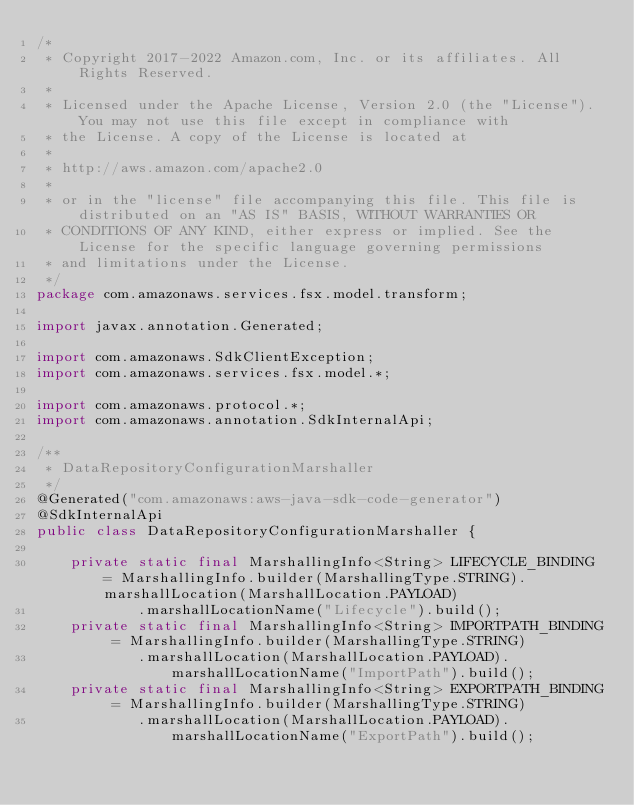Convert code to text. <code><loc_0><loc_0><loc_500><loc_500><_Java_>/*
 * Copyright 2017-2022 Amazon.com, Inc. or its affiliates. All Rights Reserved.
 * 
 * Licensed under the Apache License, Version 2.0 (the "License"). You may not use this file except in compliance with
 * the License. A copy of the License is located at
 * 
 * http://aws.amazon.com/apache2.0
 * 
 * or in the "license" file accompanying this file. This file is distributed on an "AS IS" BASIS, WITHOUT WARRANTIES OR
 * CONDITIONS OF ANY KIND, either express or implied. See the License for the specific language governing permissions
 * and limitations under the License.
 */
package com.amazonaws.services.fsx.model.transform;

import javax.annotation.Generated;

import com.amazonaws.SdkClientException;
import com.amazonaws.services.fsx.model.*;

import com.amazonaws.protocol.*;
import com.amazonaws.annotation.SdkInternalApi;

/**
 * DataRepositoryConfigurationMarshaller
 */
@Generated("com.amazonaws:aws-java-sdk-code-generator")
@SdkInternalApi
public class DataRepositoryConfigurationMarshaller {

    private static final MarshallingInfo<String> LIFECYCLE_BINDING = MarshallingInfo.builder(MarshallingType.STRING).marshallLocation(MarshallLocation.PAYLOAD)
            .marshallLocationName("Lifecycle").build();
    private static final MarshallingInfo<String> IMPORTPATH_BINDING = MarshallingInfo.builder(MarshallingType.STRING)
            .marshallLocation(MarshallLocation.PAYLOAD).marshallLocationName("ImportPath").build();
    private static final MarshallingInfo<String> EXPORTPATH_BINDING = MarshallingInfo.builder(MarshallingType.STRING)
            .marshallLocation(MarshallLocation.PAYLOAD).marshallLocationName("ExportPath").build();</code> 